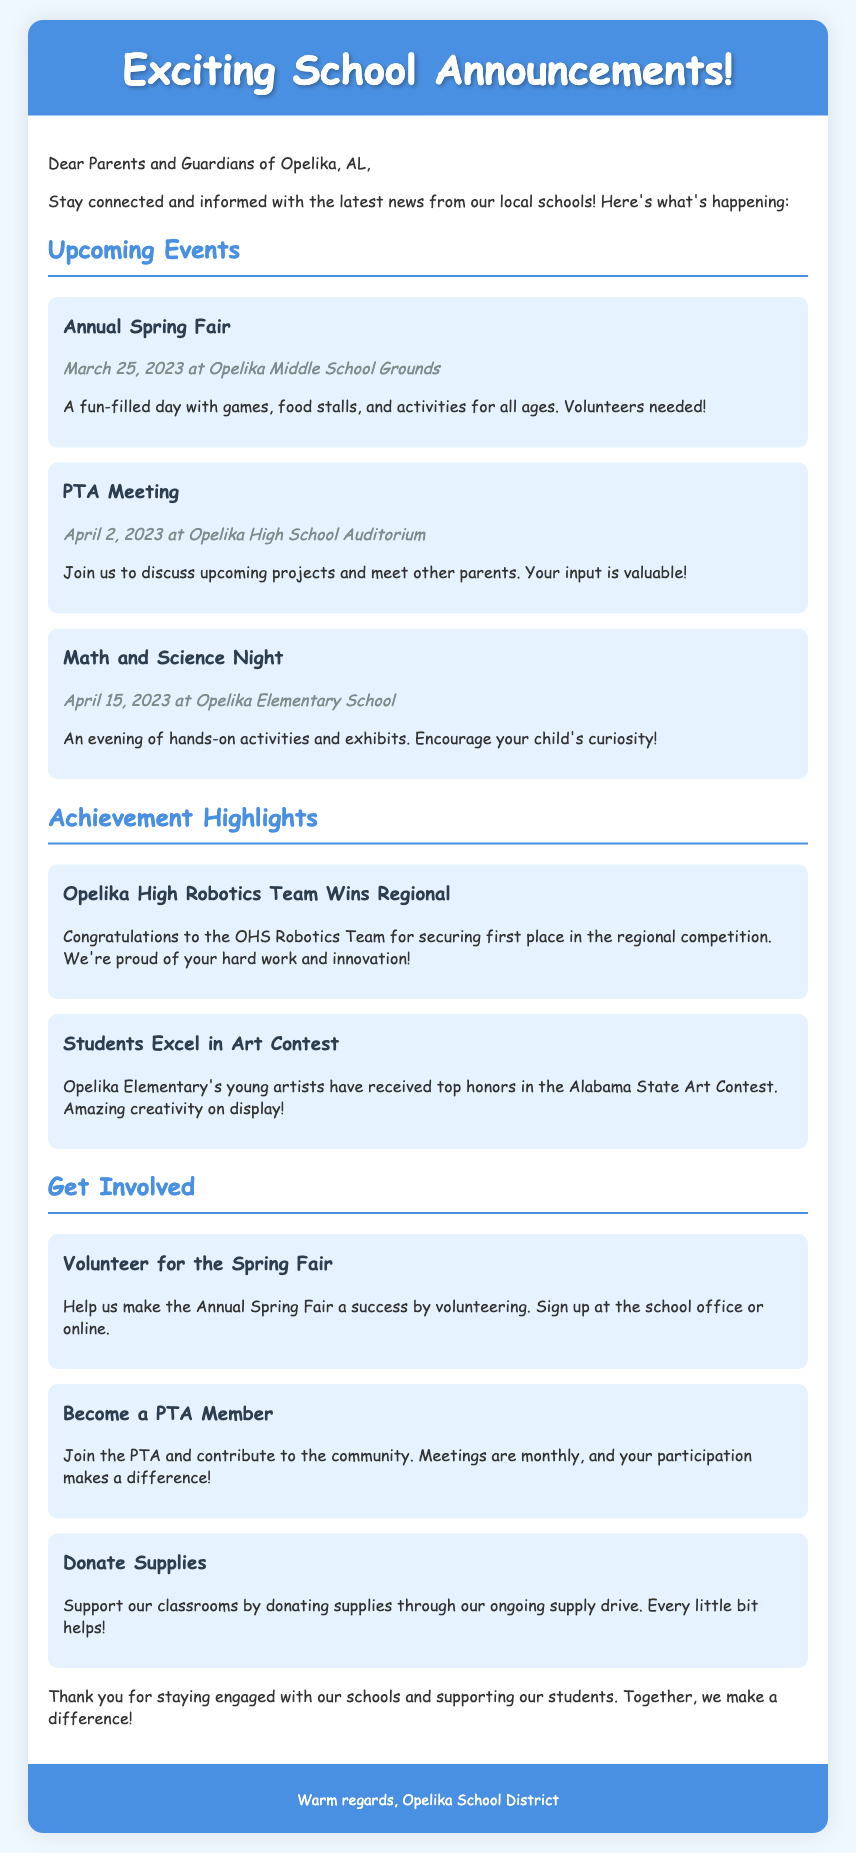what is the date of the Annual Spring Fair? The Annual Spring Fair is scheduled for March 25, 2023.
Answer: March 25, 2023 where is the PTA Meeting held? The PTA Meeting will be held at the Opelika High School Auditorium.
Answer: Opelika High School Auditorium which team won the regional competition? The OHS Robotics Team won the regional competition.
Answer: OHS Robotics Team what is one way parents can get involved? Parents can volunteer for the Annual Spring Fair.
Answer: Volunteer for the Spring Fair how many achievement highlights are mentioned in the document? There are two achievement highlights mentioned in the document.
Answer: Two when is the Math and Science Night? The Math and Science Night is on April 15, 2023.
Answer: April 15, 2023 what type of event is the Math and Science Night? The Math and Science Night is an evening of hands-on activities and exhibits.
Answer: Hands-on activities and exhibits who should parents contact to sign up for volunteering? Parents can sign up at the school office or online.
Answer: School office or online what organization can parents join for community involvement? Parents can join the PTA to contribute to the community.
Answer: PTA 